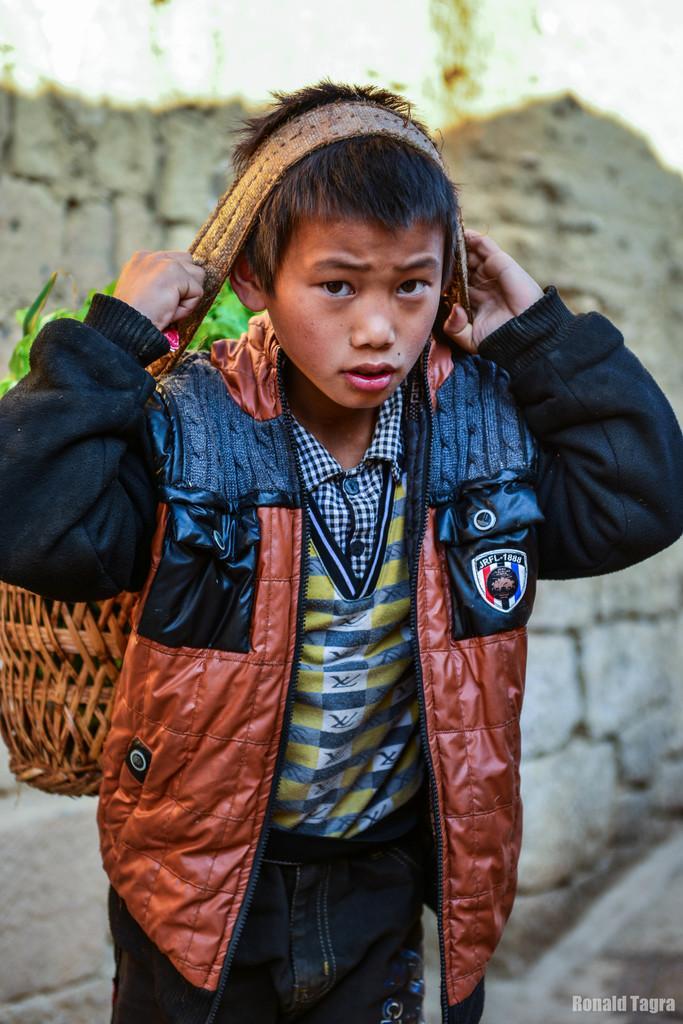Could you give a brief overview of what you see in this image? In the foreground of this image, there is a boy wearing a jacket and carrying a basket by putting the belt of it on his head. In the background, there is the wall. 